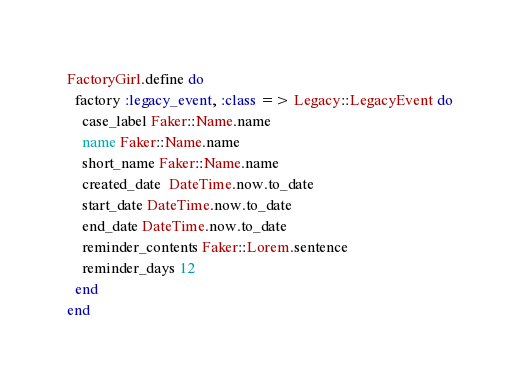<code> <loc_0><loc_0><loc_500><loc_500><_Ruby_>FactoryGirl.define do
  factory :legacy_event, :class => Legacy::LegacyEvent do
    case_label Faker::Name.name
    name Faker::Name.name
    short_name Faker::Name.name
    created_date  DateTime.now.to_date
    start_date DateTime.now.to_date
    end_date DateTime.now.to_date
    reminder_contents Faker::Lorem.sentence
    reminder_days 12
  end
end
</code> 